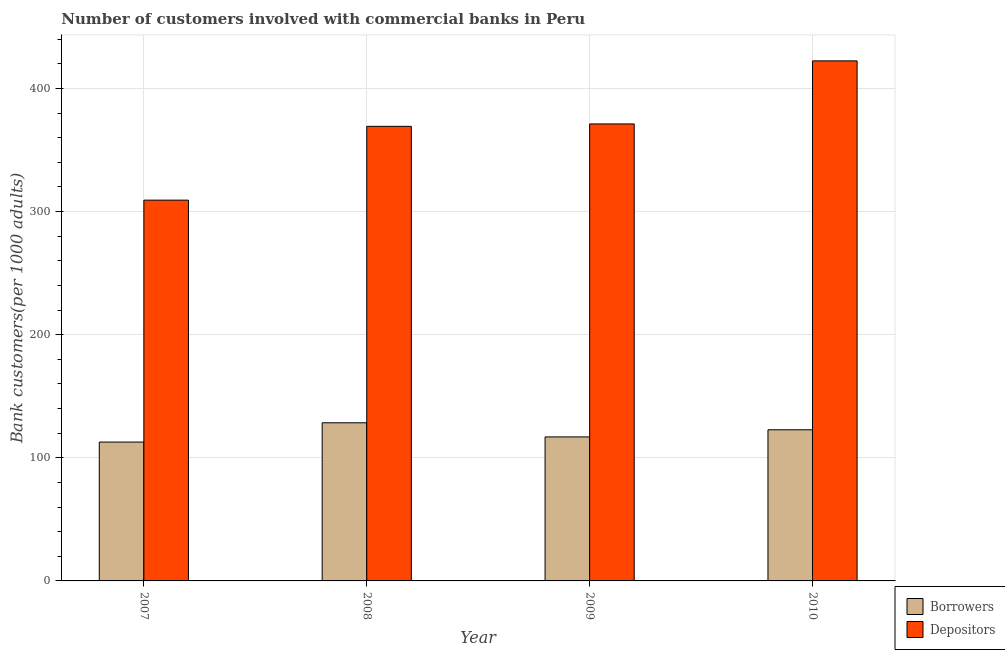How many groups of bars are there?
Offer a very short reply. 4. Are the number of bars on each tick of the X-axis equal?
Make the answer very short. Yes. How many bars are there on the 3rd tick from the left?
Your answer should be very brief. 2. How many bars are there on the 4th tick from the right?
Your answer should be compact. 2. What is the label of the 1st group of bars from the left?
Ensure brevity in your answer.  2007. What is the number of borrowers in 2007?
Offer a terse response. 112.76. Across all years, what is the maximum number of depositors?
Your answer should be very brief. 422.34. Across all years, what is the minimum number of depositors?
Your response must be concise. 309.23. In which year was the number of borrowers maximum?
Give a very brief answer. 2008. In which year was the number of borrowers minimum?
Ensure brevity in your answer.  2007. What is the total number of borrowers in the graph?
Ensure brevity in your answer.  480.89. What is the difference between the number of depositors in 2007 and that in 2010?
Keep it short and to the point. -113.11. What is the difference between the number of depositors in 2009 and the number of borrowers in 2007?
Offer a very short reply. 61.9. What is the average number of depositors per year?
Keep it short and to the point. 367.97. In how many years, is the number of depositors greater than 120?
Ensure brevity in your answer.  4. What is the ratio of the number of borrowers in 2007 to that in 2009?
Give a very brief answer. 0.96. Is the number of depositors in 2007 less than that in 2008?
Offer a terse response. Yes. Is the difference between the number of borrowers in 2007 and 2008 greater than the difference between the number of depositors in 2007 and 2008?
Your response must be concise. No. What is the difference between the highest and the second highest number of borrowers?
Ensure brevity in your answer.  5.67. What is the difference between the highest and the lowest number of borrowers?
Make the answer very short. 15.66. In how many years, is the number of borrowers greater than the average number of borrowers taken over all years?
Your response must be concise. 2. What does the 1st bar from the left in 2010 represents?
Keep it short and to the point. Borrowers. What does the 1st bar from the right in 2008 represents?
Your answer should be very brief. Depositors. What is the difference between two consecutive major ticks on the Y-axis?
Offer a very short reply. 100. Are the values on the major ticks of Y-axis written in scientific E-notation?
Ensure brevity in your answer.  No. Does the graph contain any zero values?
Your response must be concise. No. Does the graph contain grids?
Make the answer very short. Yes. How are the legend labels stacked?
Provide a succinct answer. Vertical. What is the title of the graph?
Your answer should be compact. Number of customers involved with commercial banks in Peru. What is the label or title of the Y-axis?
Keep it short and to the point. Bank customers(per 1000 adults). What is the Bank customers(per 1000 adults) in Borrowers in 2007?
Make the answer very short. 112.76. What is the Bank customers(per 1000 adults) in Depositors in 2007?
Offer a very short reply. 309.23. What is the Bank customers(per 1000 adults) of Borrowers in 2008?
Your answer should be very brief. 128.42. What is the Bank customers(per 1000 adults) of Depositors in 2008?
Your answer should be very brief. 369.17. What is the Bank customers(per 1000 adults) of Borrowers in 2009?
Ensure brevity in your answer.  116.95. What is the Bank customers(per 1000 adults) of Depositors in 2009?
Offer a terse response. 371.13. What is the Bank customers(per 1000 adults) in Borrowers in 2010?
Offer a very short reply. 122.75. What is the Bank customers(per 1000 adults) in Depositors in 2010?
Ensure brevity in your answer.  422.34. Across all years, what is the maximum Bank customers(per 1000 adults) of Borrowers?
Your answer should be compact. 128.42. Across all years, what is the maximum Bank customers(per 1000 adults) of Depositors?
Provide a succinct answer. 422.34. Across all years, what is the minimum Bank customers(per 1000 adults) of Borrowers?
Ensure brevity in your answer.  112.76. Across all years, what is the minimum Bank customers(per 1000 adults) of Depositors?
Your answer should be compact. 309.23. What is the total Bank customers(per 1000 adults) of Borrowers in the graph?
Your response must be concise. 480.89. What is the total Bank customers(per 1000 adults) of Depositors in the graph?
Your response must be concise. 1471.87. What is the difference between the Bank customers(per 1000 adults) of Borrowers in 2007 and that in 2008?
Offer a terse response. -15.66. What is the difference between the Bank customers(per 1000 adults) in Depositors in 2007 and that in 2008?
Give a very brief answer. -59.93. What is the difference between the Bank customers(per 1000 adults) of Borrowers in 2007 and that in 2009?
Provide a succinct answer. -4.19. What is the difference between the Bank customers(per 1000 adults) in Depositors in 2007 and that in 2009?
Give a very brief answer. -61.9. What is the difference between the Bank customers(per 1000 adults) of Borrowers in 2007 and that in 2010?
Your answer should be very brief. -9.99. What is the difference between the Bank customers(per 1000 adults) in Depositors in 2007 and that in 2010?
Provide a short and direct response. -113.11. What is the difference between the Bank customers(per 1000 adults) of Borrowers in 2008 and that in 2009?
Keep it short and to the point. 11.47. What is the difference between the Bank customers(per 1000 adults) in Depositors in 2008 and that in 2009?
Give a very brief answer. -1.97. What is the difference between the Bank customers(per 1000 adults) of Borrowers in 2008 and that in 2010?
Offer a terse response. 5.67. What is the difference between the Bank customers(per 1000 adults) of Depositors in 2008 and that in 2010?
Your answer should be very brief. -53.18. What is the difference between the Bank customers(per 1000 adults) of Borrowers in 2009 and that in 2010?
Offer a terse response. -5.8. What is the difference between the Bank customers(per 1000 adults) in Depositors in 2009 and that in 2010?
Your response must be concise. -51.21. What is the difference between the Bank customers(per 1000 adults) in Borrowers in 2007 and the Bank customers(per 1000 adults) in Depositors in 2008?
Your answer should be compact. -256.4. What is the difference between the Bank customers(per 1000 adults) in Borrowers in 2007 and the Bank customers(per 1000 adults) in Depositors in 2009?
Offer a terse response. -258.37. What is the difference between the Bank customers(per 1000 adults) in Borrowers in 2007 and the Bank customers(per 1000 adults) in Depositors in 2010?
Offer a terse response. -309.58. What is the difference between the Bank customers(per 1000 adults) in Borrowers in 2008 and the Bank customers(per 1000 adults) in Depositors in 2009?
Keep it short and to the point. -242.71. What is the difference between the Bank customers(per 1000 adults) in Borrowers in 2008 and the Bank customers(per 1000 adults) in Depositors in 2010?
Provide a short and direct response. -293.92. What is the difference between the Bank customers(per 1000 adults) in Borrowers in 2009 and the Bank customers(per 1000 adults) in Depositors in 2010?
Your answer should be very brief. -305.39. What is the average Bank customers(per 1000 adults) of Borrowers per year?
Provide a short and direct response. 120.22. What is the average Bank customers(per 1000 adults) in Depositors per year?
Keep it short and to the point. 367.97. In the year 2007, what is the difference between the Bank customers(per 1000 adults) of Borrowers and Bank customers(per 1000 adults) of Depositors?
Offer a very short reply. -196.47. In the year 2008, what is the difference between the Bank customers(per 1000 adults) of Borrowers and Bank customers(per 1000 adults) of Depositors?
Make the answer very short. -240.75. In the year 2009, what is the difference between the Bank customers(per 1000 adults) of Borrowers and Bank customers(per 1000 adults) of Depositors?
Make the answer very short. -254.18. In the year 2010, what is the difference between the Bank customers(per 1000 adults) of Borrowers and Bank customers(per 1000 adults) of Depositors?
Make the answer very short. -299.59. What is the ratio of the Bank customers(per 1000 adults) in Borrowers in 2007 to that in 2008?
Offer a very short reply. 0.88. What is the ratio of the Bank customers(per 1000 adults) of Depositors in 2007 to that in 2008?
Offer a very short reply. 0.84. What is the ratio of the Bank customers(per 1000 adults) in Borrowers in 2007 to that in 2009?
Ensure brevity in your answer.  0.96. What is the ratio of the Bank customers(per 1000 adults) in Depositors in 2007 to that in 2009?
Offer a very short reply. 0.83. What is the ratio of the Bank customers(per 1000 adults) in Borrowers in 2007 to that in 2010?
Offer a very short reply. 0.92. What is the ratio of the Bank customers(per 1000 adults) in Depositors in 2007 to that in 2010?
Keep it short and to the point. 0.73. What is the ratio of the Bank customers(per 1000 adults) of Borrowers in 2008 to that in 2009?
Ensure brevity in your answer.  1.1. What is the ratio of the Bank customers(per 1000 adults) of Borrowers in 2008 to that in 2010?
Provide a succinct answer. 1.05. What is the ratio of the Bank customers(per 1000 adults) in Depositors in 2008 to that in 2010?
Keep it short and to the point. 0.87. What is the ratio of the Bank customers(per 1000 adults) in Borrowers in 2009 to that in 2010?
Provide a short and direct response. 0.95. What is the ratio of the Bank customers(per 1000 adults) of Depositors in 2009 to that in 2010?
Provide a succinct answer. 0.88. What is the difference between the highest and the second highest Bank customers(per 1000 adults) of Borrowers?
Offer a very short reply. 5.67. What is the difference between the highest and the second highest Bank customers(per 1000 adults) in Depositors?
Give a very brief answer. 51.21. What is the difference between the highest and the lowest Bank customers(per 1000 adults) in Borrowers?
Make the answer very short. 15.66. What is the difference between the highest and the lowest Bank customers(per 1000 adults) of Depositors?
Offer a very short reply. 113.11. 